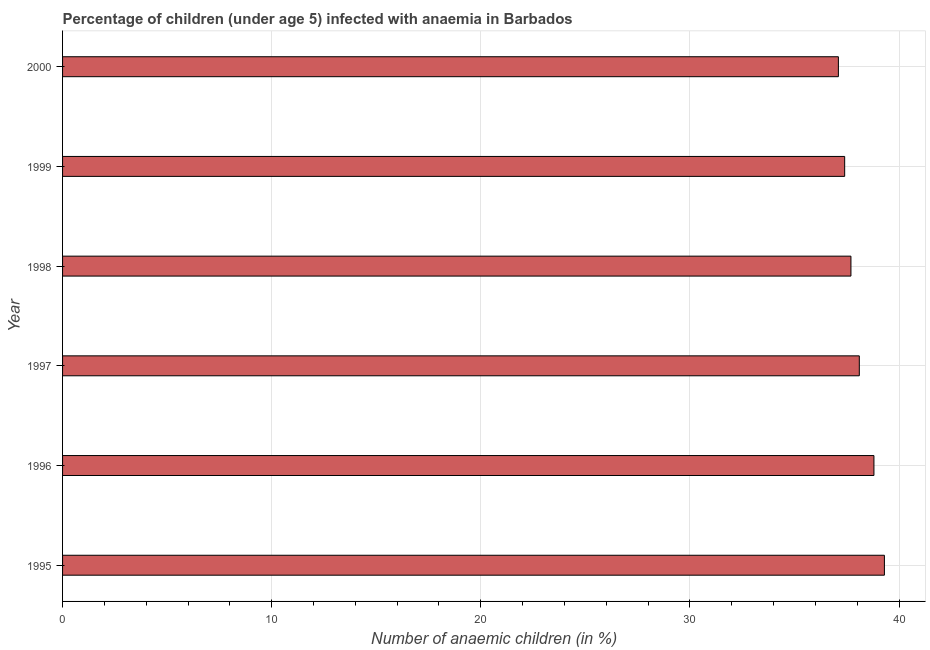Does the graph contain any zero values?
Provide a succinct answer. No. What is the title of the graph?
Make the answer very short. Percentage of children (under age 5) infected with anaemia in Barbados. What is the label or title of the X-axis?
Make the answer very short. Number of anaemic children (in %). What is the label or title of the Y-axis?
Give a very brief answer. Year. What is the number of anaemic children in 1997?
Make the answer very short. 38.1. Across all years, what is the maximum number of anaemic children?
Provide a short and direct response. 39.3. Across all years, what is the minimum number of anaemic children?
Give a very brief answer. 37.1. In which year was the number of anaemic children maximum?
Provide a succinct answer. 1995. In which year was the number of anaemic children minimum?
Your answer should be compact. 2000. What is the sum of the number of anaemic children?
Give a very brief answer. 228.4. What is the average number of anaemic children per year?
Provide a short and direct response. 38.07. What is the median number of anaemic children?
Your answer should be very brief. 37.9. What is the ratio of the number of anaemic children in 1998 to that in 2000?
Your answer should be compact. 1.02. Is the number of anaemic children in 1995 less than that in 1996?
Give a very brief answer. No. Is the difference between the number of anaemic children in 1995 and 1997 greater than the difference between any two years?
Keep it short and to the point. No. Is the sum of the number of anaemic children in 1995 and 1998 greater than the maximum number of anaemic children across all years?
Provide a succinct answer. Yes. What is the difference between the highest and the lowest number of anaemic children?
Offer a terse response. 2.2. Are all the bars in the graph horizontal?
Provide a short and direct response. Yes. What is the Number of anaemic children (in %) in 1995?
Your answer should be compact. 39.3. What is the Number of anaemic children (in %) of 1996?
Your answer should be very brief. 38.8. What is the Number of anaemic children (in %) in 1997?
Keep it short and to the point. 38.1. What is the Number of anaemic children (in %) of 1998?
Your answer should be very brief. 37.7. What is the Number of anaemic children (in %) of 1999?
Your response must be concise. 37.4. What is the Number of anaemic children (in %) of 2000?
Provide a short and direct response. 37.1. What is the difference between the Number of anaemic children (in %) in 1995 and 1996?
Keep it short and to the point. 0.5. What is the difference between the Number of anaemic children (in %) in 1995 and 2000?
Your answer should be very brief. 2.2. What is the difference between the Number of anaemic children (in %) in 1996 and 1998?
Make the answer very short. 1.1. What is the difference between the Number of anaemic children (in %) in 1996 and 2000?
Give a very brief answer. 1.7. What is the difference between the Number of anaemic children (in %) in 1997 and 1998?
Your answer should be very brief. 0.4. What is the difference between the Number of anaemic children (in %) in 1997 and 2000?
Ensure brevity in your answer.  1. What is the difference between the Number of anaemic children (in %) in 1998 and 1999?
Give a very brief answer. 0.3. What is the difference between the Number of anaemic children (in %) in 1998 and 2000?
Keep it short and to the point. 0.6. What is the difference between the Number of anaemic children (in %) in 1999 and 2000?
Your answer should be very brief. 0.3. What is the ratio of the Number of anaemic children (in %) in 1995 to that in 1997?
Provide a succinct answer. 1.03. What is the ratio of the Number of anaemic children (in %) in 1995 to that in 1998?
Ensure brevity in your answer.  1.04. What is the ratio of the Number of anaemic children (in %) in 1995 to that in 1999?
Keep it short and to the point. 1.05. What is the ratio of the Number of anaemic children (in %) in 1995 to that in 2000?
Provide a short and direct response. 1.06. What is the ratio of the Number of anaemic children (in %) in 1996 to that in 1997?
Ensure brevity in your answer.  1.02. What is the ratio of the Number of anaemic children (in %) in 1996 to that in 2000?
Your response must be concise. 1.05. What is the ratio of the Number of anaemic children (in %) in 1997 to that in 2000?
Keep it short and to the point. 1.03. What is the ratio of the Number of anaemic children (in %) in 1998 to that in 1999?
Keep it short and to the point. 1.01. What is the ratio of the Number of anaemic children (in %) in 1998 to that in 2000?
Provide a short and direct response. 1.02. What is the ratio of the Number of anaemic children (in %) in 1999 to that in 2000?
Give a very brief answer. 1.01. 